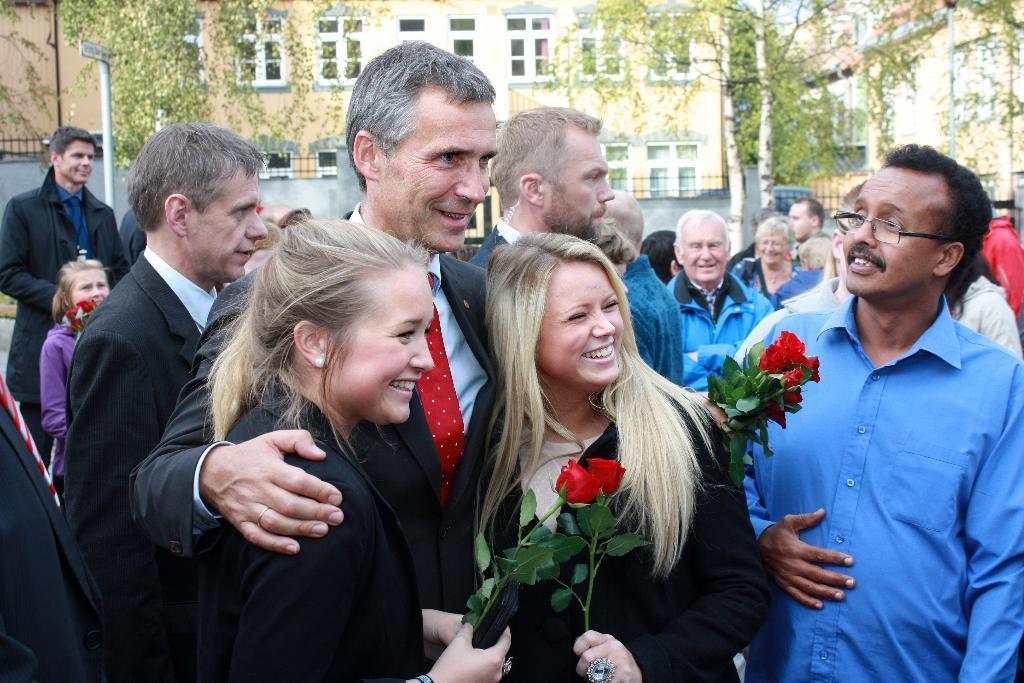Describe this image in one or two sentences. In this picture we can see some people standing, these three persons are holding rose flowers, in the background there is a building, we can see trees here, on the left side there is a pole. 